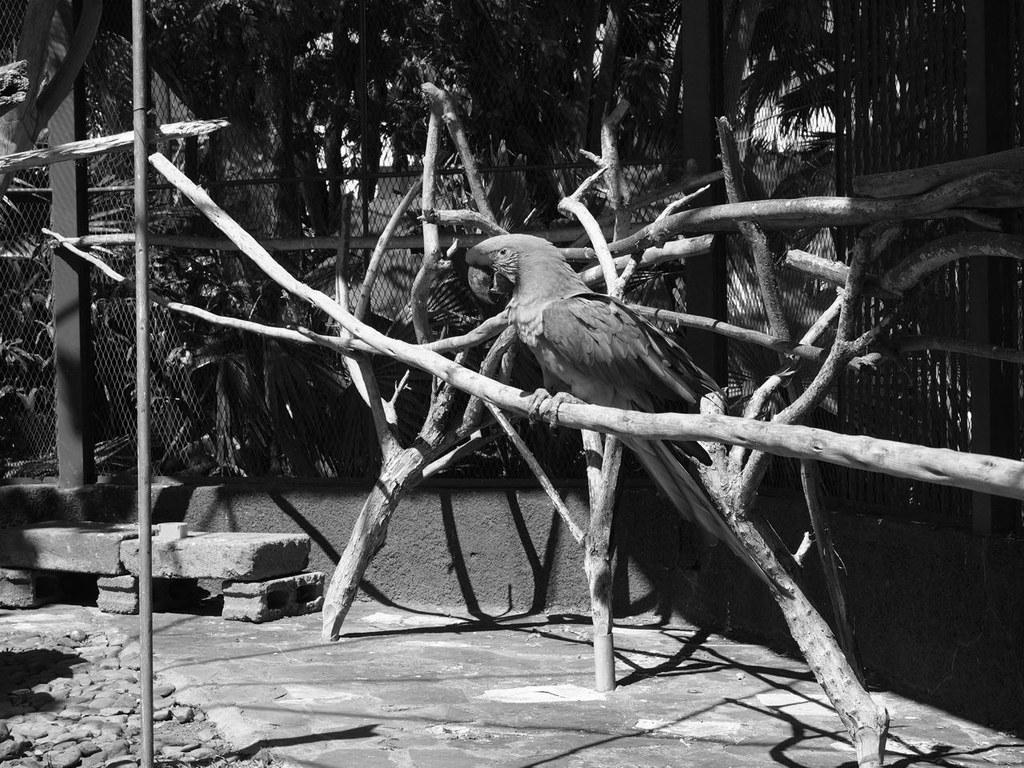Could you give a brief overview of what you see in this image? In this black and white image, there is a bird sitting on the wood, on the left side we can see some stones and in the background we can see some trees. 